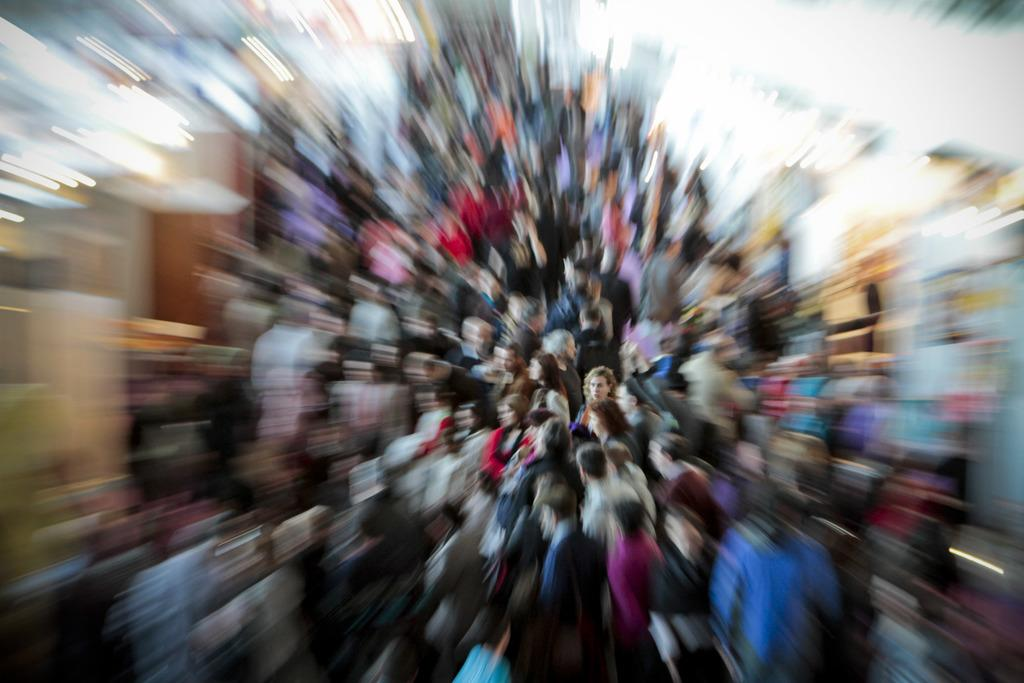What is the main subject of the image? The main subject of the image is a group of people. Can you describe the background of the image? The background of the image is blurred. What is the average income of the people in the image? There is no information about the income of the people in the image, as it is not relevant to the visual content. 